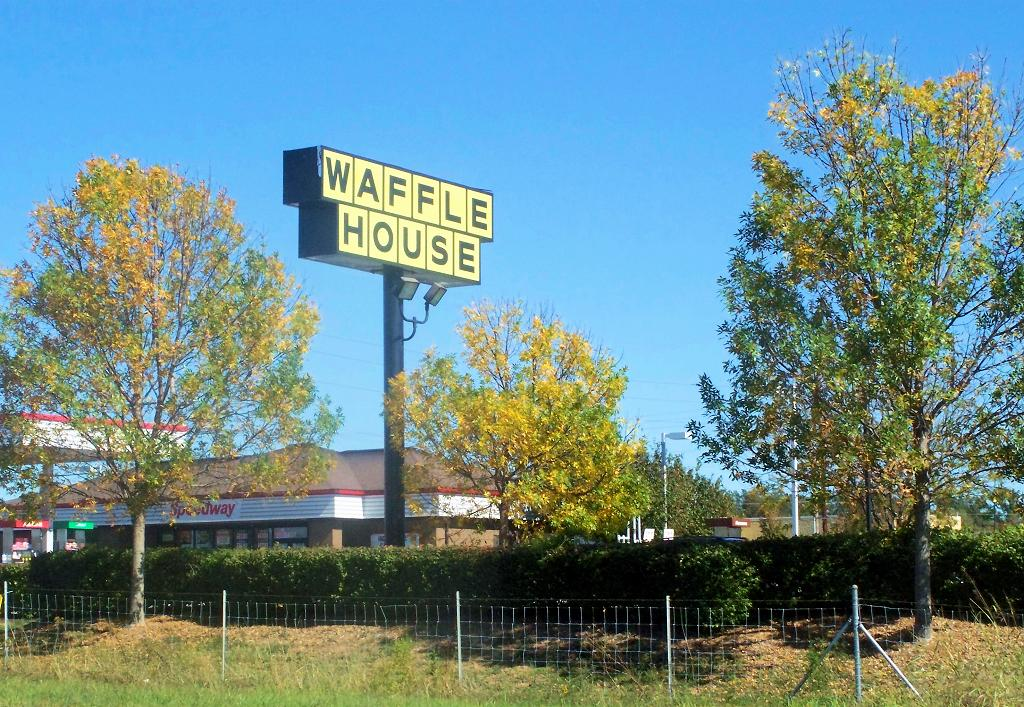What type of structures can be seen in the image? There are buildings in the image. What is the purpose of the name board in the image? The name board in the image is likely used for identification or direction. What type of lighting is visible in the image? Electric lights are visible in the image. What type of vegetation is present in the image? Trees, bushes, and grass are visible in the image. What type of barrier is present in the image? There is a fence in the image. What can be seen in the background of the image? The sky is visible in the background of the image. What type of business is being conducted in the image? The image does not depict any specific business activity; it shows buildings, a name board, electric lights, trees, bushes, grass, a fence, and the sky. What part of the world is the image taken from? The image does not provide any information about its geographical location. 